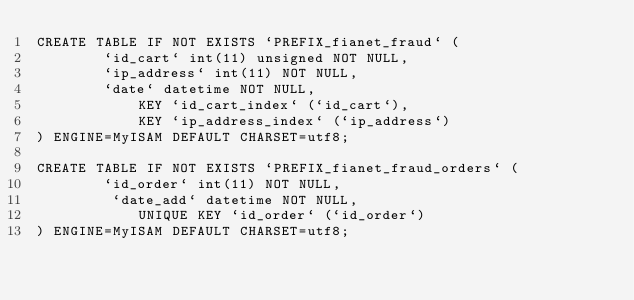Convert code to text. <code><loc_0><loc_0><loc_500><loc_500><_SQL_>CREATE TABLE IF NOT EXISTS `PREFIX_fianet_fraud` (
		`id_cart` int(11) unsigned NOT NULL,
		`ip_address` int(11) NOT NULL,
		`date` datetime NOT NULL,
			KEY `id_cart_index` (`id_cart`),
			KEY `ip_address_index` (`ip_address`)
) ENGINE=MyISAM DEFAULT CHARSET=utf8;

CREATE TABLE IF NOT EXISTS `PREFIX_fianet_fraud_orders` (
		`id_order` int(11) NOT NULL,
		 `date_add` datetime NOT NULL,
			UNIQUE KEY `id_order` (`id_order`)
) ENGINE=MyISAM DEFAULT CHARSET=utf8;
</code> 